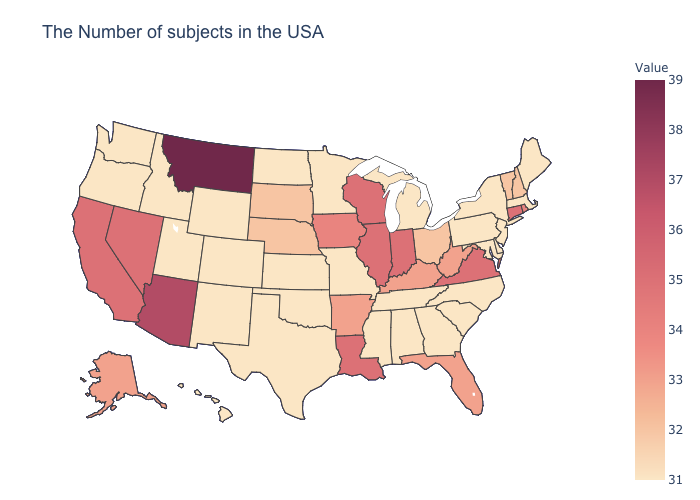Among the states that border Massachusetts , which have the lowest value?
Concise answer only. New York. Does the map have missing data?
Give a very brief answer. No. Does Connecticut have the highest value in the Northeast?
Concise answer only. Yes. Is the legend a continuous bar?
Write a very short answer. Yes. Which states hav the highest value in the MidWest?
Quick response, please. Indiana, Wisconsin, Illinois. Which states have the lowest value in the MidWest?
Concise answer only. Michigan, Missouri, Minnesota, Kansas, North Dakota. Does New Jersey have the lowest value in the USA?
Be succinct. Yes. Is the legend a continuous bar?
Give a very brief answer. Yes. 